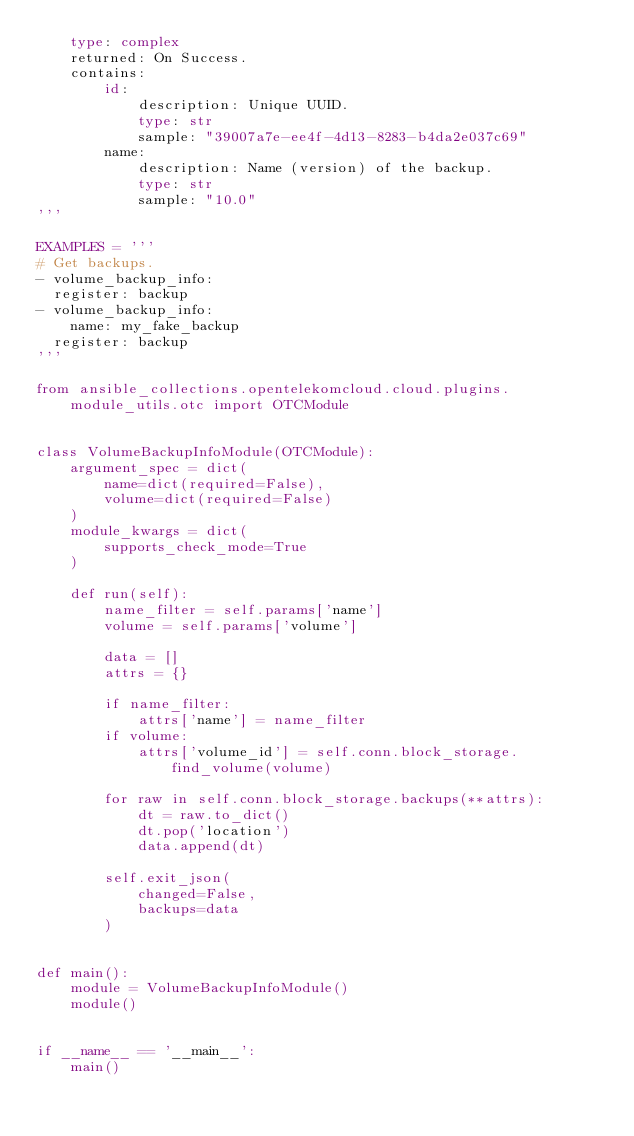<code> <loc_0><loc_0><loc_500><loc_500><_Python_>    type: complex
    returned: On Success.
    contains:
        id:
            description: Unique UUID.
            type: str
            sample: "39007a7e-ee4f-4d13-8283-b4da2e037c69"
        name:
            description: Name (version) of the backup.
            type: str
            sample: "10.0"
'''

EXAMPLES = '''
# Get backups.
- volume_backup_info:
  register: backup
- volume_backup_info:
    name: my_fake_backup
  register: backup
'''

from ansible_collections.opentelekomcloud.cloud.plugins.module_utils.otc import OTCModule


class VolumeBackupInfoModule(OTCModule):
    argument_spec = dict(
        name=dict(required=False),
        volume=dict(required=False)
    )
    module_kwargs = dict(
        supports_check_mode=True
    )

    def run(self):
        name_filter = self.params['name']
        volume = self.params['volume']

        data = []
        attrs = {}

        if name_filter:
            attrs['name'] = name_filter
        if volume:
            attrs['volume_id'] = self.conn.block_storage.find_volume(volume)

        for raw in self.conn.block_storage.backups(**attrs):
            dt = raw.to_dict()
            dt.pop('location')
            data.append(dt)

        self.exit_json(
            changed=False,
            backups=data
        )


def main():
    module = VolumeBackupInfoModule()
    module()


if __name__ == '__main__':
    main()
</code> 